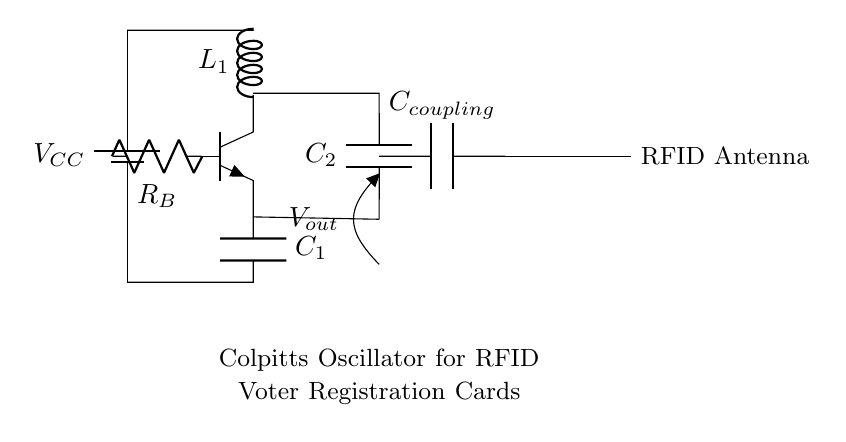What is the power supply voltage? The power supply voltage is indicated by the label near the battery symbol in the circuit. It is denoted as VCC.
Answer: VCC What type of transducer is shown in this circuit? The circuit diagram includes an "antenna" symbol, which represents an RFID antenna. This transducer is used for radio frequency identification in the context of the circuit.
Answer: RFID antenna What is the role of capacitor C1? Capacitor C1 is connected to the emitter of the transistor and serves to create feedback in the Colpitts oscillator circuit that sustains oscillations.
Answer: Feedback What is the relationship between C2 and Ccoupling? Capacitor C2 is connected in parallel to capacitor Ccoupling. C2 helps to set the frequency of the oscillation while Ccoupling connects the oscillator to the RFID antenna circuit.
Answer: Parallel How many capacitors are in the oscillator circuit? The circuit contains two capacitors: C1 and C2. Additionally, there is one coupling capacitor (Ccoupling), making the total three capacitors in the schematic.
Answer: Three Which component provides the inductive reactance? The component that provides inductive reactance in this Colpitts oscillator circuit is labeled as L1, which is an inductor connected to the transistor's collector.
Answer: L1 What function does the resistor Rb serve? Resistor Rb is connected to the base of the transistor, functioning as a biasing resistor that controls the base current and helps to stabilize the transistor's operation in the oscillator configuration.
Answer: Biasing 